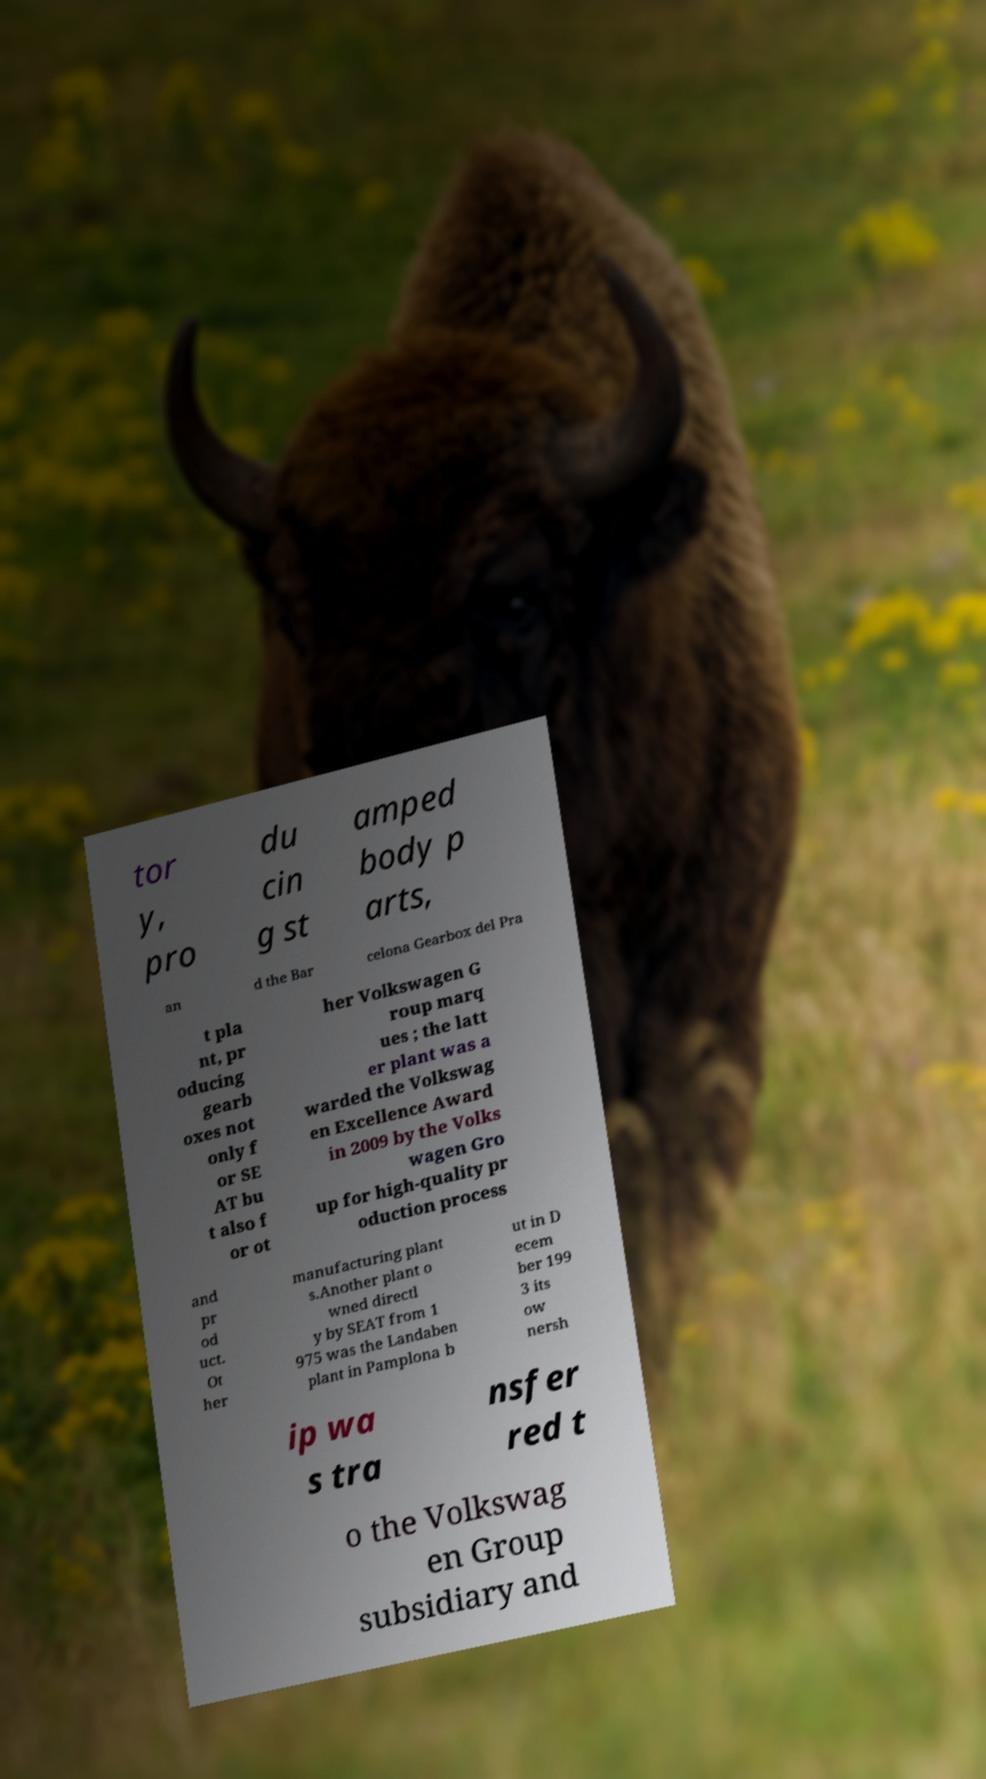Can you accurately transcribe the text from the provided image for me? tor y, pro du cin g st amped body p arts, an d the Bar celona Gearbox del Pra t pla nt, pr oducing gearb oxes not only f or SE AT bu t also f or ot her Volkswagen G roup marq ues ; the latt er plant was a warded the Volkswag en Excellence Award in 2009 by the Volks wagen Gro up for high-quality pr oduction process and pr od uct. Ot her manufacturing plant s.Another plant o wned directl y by SEAT from 1 975 was the Landaben plant in Pamplona b ut in D ecem ber 199 3 its ow nersh ip wa s tra nsfer red t o the Volkswag en Group subsidiary and 